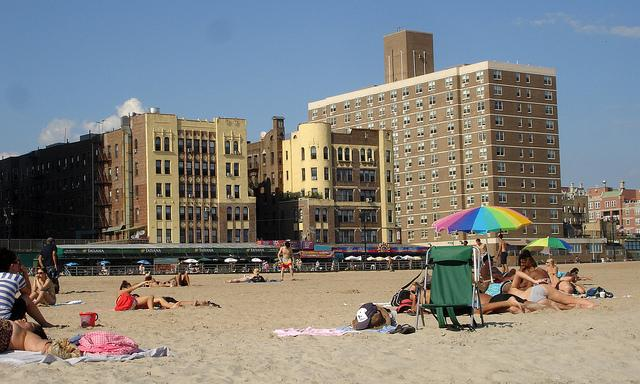Where is someone who might easily overheat safest here? Please explain your reasoning. under umbrella. They could go to the umbrella. 